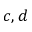Convert formula to latex. <formula><loc_0><loc_0><loc_500><loc_500>c , d</formula> 